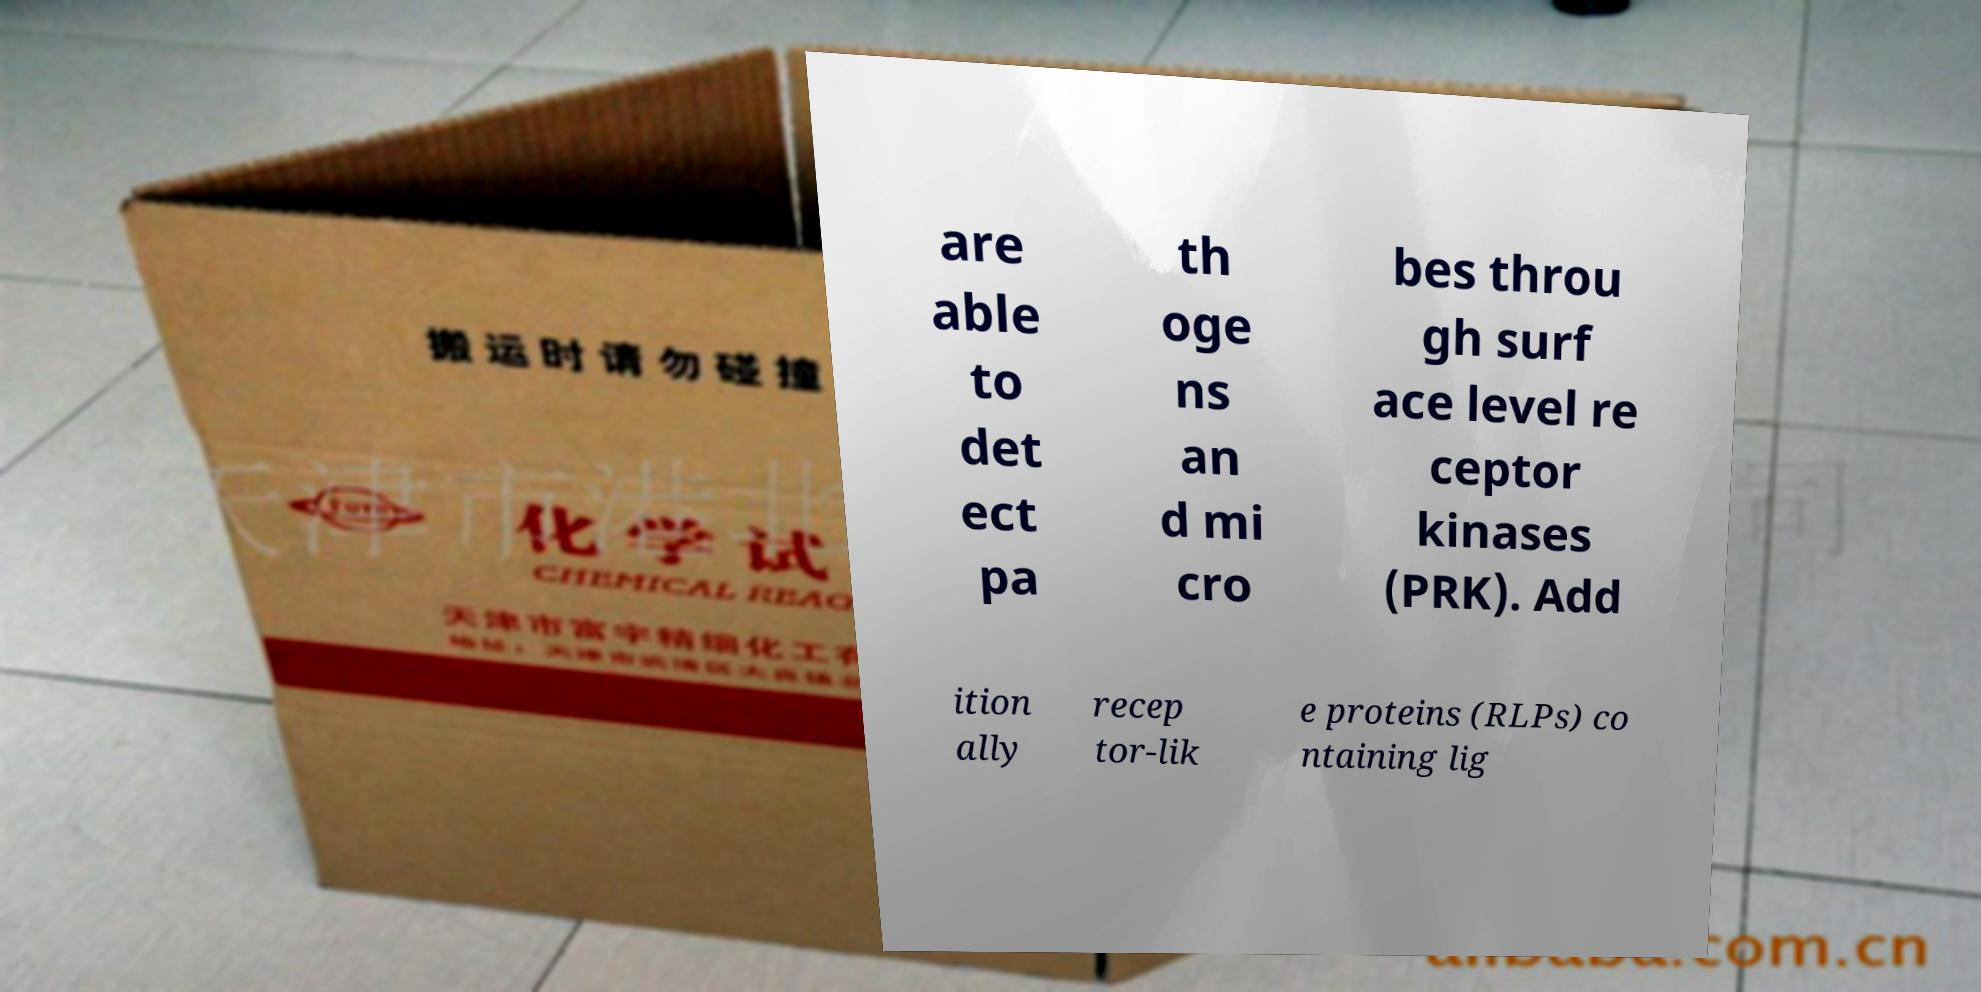There's text embedded in this image that I need extracted. Can you transcribe it verbatim? are able to det ect pa th oge ns an d mi cro bes throu gh surf ace level re ceptor kinases (PRK). Add ition ally recep tor-lik e proteins (RLPs) co ntaining lig 